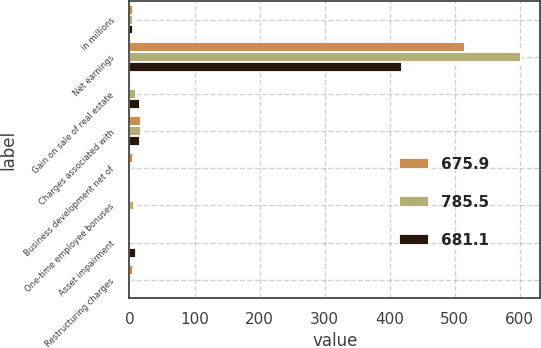<chart> <loc_0><loc_0><loc_500><loc_500><stacked_bar_chart><ecel><fcel>in millions<fcel>Net earnings<fcel>Gain on sale of real estate<fcel>Charges associated with<fcel>Business development net of<fcel>One-time employee bonuses<fcel>Asset impairment<fcel>Restructuring charges<nl><fcel>675.9<fcel>6.2<fcel>515.8<fcel>2.9<fcel>18.5<fcel>5.2<fcel>0<fcel>0<fcel>6.2<nl><fcel>785.5<fcel>6.2<fcel>601.2<fcel>10.5<fcel>18.1<fcel>3.1<fcel>6.7<fcel>0<fcel>1.9<nl><fcel>681.1<fcel>6.2<fcel>419.5<fcel>16.2<fcel>16.9<fcel>0<fcel>0<fcel>10.5<fcel>0.3<nl></chart> 